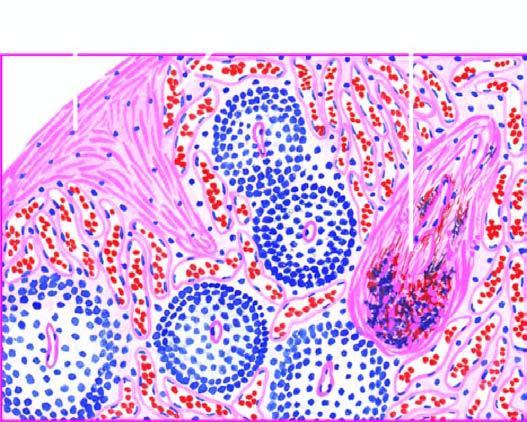what is there increased in the red pulp, capsule and the trabeculae?
Answer the question using a single word or phrase. Fibrosis 